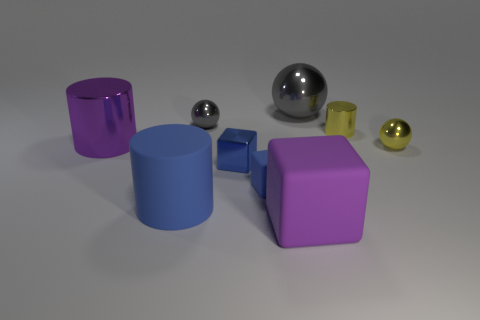How many other big cylinders have the same material as the purple cylinder?
Offer a terse response. 0. Are there fewer tiny blue things on the left side of the blue metal object than tiny brown metallic balls?
Keep it short and to the point. No. Are there any purple cylinders on the right side of the big purple thing that is behind the blue shiny block?
Make the answer very short. No. Is there anything else that has the same shape as the tiny gray shiny object?
Make the answer very short. Yes. Do the blue cylinder and the purple rubber object have the same size?
Your response must be concise. Yes. The tiny sphere that is left of the big object behind the metallic thing that is to the left of the small gray object is made of what material?
Ensure brevity in your answer.  Metal. Are there an equal number of shiny things that are on the right side of the big cube and yellow metal spheres?
Provide a short and direct response. No. Are there any other things that are the same size as the blue metallic cube?
Your response must be concise. Yes. What number of objects are either tiny blue objects or small blue shiny things?
Keep it short and to the point. 2. There is a purple thing that is made of the same material as the blue cylinder; what shape is it?
Your response must be concise. Cube. 